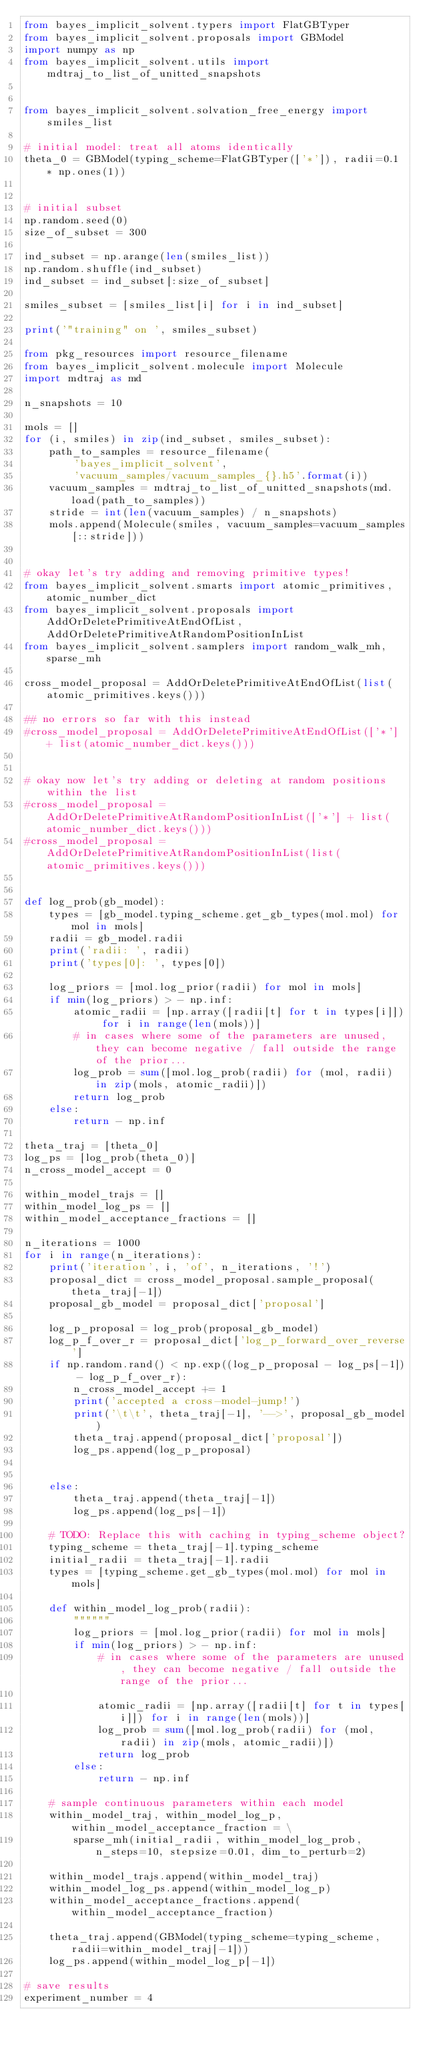Convert code to text. <code><loc_0><loc_0><loc_500><loc_500><_Python_>from bayes_implicit_solvent.typers import FlatGBTyper
from bayes_implicit_solvent.proposals import GBModel
import numpy as np
from bayes_implicit_solvent.utils import mdtraj_to_list_of_unitted_snapshots


from bayes_implicit_solvent.solvation_free_energy import smiles_list

# initial model: treat all atoms identically
theta_0 = GBModel(typing_scheme=FlatGBTyper(['*']), radii=0.1 * np.ones(1))


# initial subset
np.random.seed(0)
size_of_subset = 300

ind_subset = np.arange(len(smiles_list))
np.random.shuffle(ind_subset)
ind_subset = ind_subset[:size_of_subset]

smiles_subset = [smiles_list[i] for i in ind_subset]

print('"training" on ', smiles_subset)

from pkg_resources import resource_filename
from bayes_implicit_solvent.molecule import Molecule
import mdtraj as md

n_snapshots = 10

mols = []
for (i, smiles) in zip(ind_subset, smiles_subset):
    path_to_samples = resource_filename(
        'bayes_implicit_solvent',
        'vacuum_samples/vacuum_samples_{}.h5'.format(i))
    vacuum_samples = mdtraj_to_list_of_unitted_snapshots(md.load(path_to_samples))
    stride = int(len(vacuum_samples) / n_snapshots)
    mols.append(Molecule(smiles, vacuum_samples=vacuum_samples[::stride]))


# okay let's try adding and removing primitive types!
from bayes_implicit_solvent.smarts import atomic_primitives, atomic_number_dict
from bayes_implicit_solvent.proposals import AddOrDeletePrimitiveAtEndOfList, AddOrDeletePrimitiveAtRandomPositionInList
from bayes_implicit_solvent.samplers import random_walk_mh, sparse_mh

cross_model_proposal = AddOrDeletePrimitiveAtEndOfList(list(atomic_primitives.keys()))

## no errors so far with this instead
#cross_model_proposal = AddOrDeletePrimitiveAtEndOfList(['*'] + list(atomic_number_dict.keys()))


# okay now let's try adding or deleting at random positions within the list
#cross_model_proposal = AddOrDeletePrimitiveAtRandomPositionInList(['*'] + list(atomic_number_dict.keys()))
#cross_model_proposal = AddOrDeletePrimitiveAtRandomPositionInList(list(atomic_primitives.keys()))


def log_prob(gb_model):
    types = [gb_model.typing_scheme.get_gb_types(mol.mol) for mol in mols]
    radii = gb_model.radii
    print('radii: ', radii)
    print('types[0]: ', types[0])

    log_priors = [mol.log_prior(radii) for mol in mols]
    if min(log_priors) > - np.inf:
        atomic_radii = [np.array([radii[t] for t in types[i]]) for i in range(len(mols))]
        # in cases where some of the parameters are unused, they can become negative / fall outside the range of the prior...
        log_prob = sum([mol.log_prob(radii) for (mol, radii) in zip(mols, atomic_radii)])
        return log_prob
    else:
        return - np.inf

theta_traj = [theta_0]
log_ps = [log_prob(theta_0)]
n_cross_model_accept = 0

within_model_trajs = []
within_model_log_ps = []
within_model_acceptance_fractions = []

n_iterations = 1000
for i in range(n_iterations):
    print('iteration', i, 'of', n_iterations, '!')
    proposal_dict = cross_model_proposal.sample_proposal(theta_traj[-1])
    proposal_gb_model = proposal_dict['proposal']

    log_p_proposal = log_prob(proposal_gb_model)
    log_p_f_over_r = proposal_dict['log_p_forward_over_reverse']
    if np.random.rand() < np.exp((log_p_proposal - log_ps[-1]) - log_p_f_over_r):
        n_cross_model_accept += 1
        print('accepted a cross-model-jump!')
        print('\t\t', theta_traj[-1], '-->', proposal_gb_model)
        theta_traj.append(proposal_dict['proposal'])
        log_ps.append(log_p_proposal)


    else:
        theta_traj.append(theta_traj[-1])
        log_ps.append(log_ps[-1])

    # TODO: Replace this with caching in typing_scheme object?
    typing_scheme = theta_traj[-1].typing_scheme
    initial_radii = theta_traj[-1].radii
    types = [typing_scheme.get_gb_types(mol.mol) for mol in mols]

    def within_model_log_prob(radii):
        """"""
        log_priors = [mol.log_prior(radii) for mol in mols]
        if min(log_priors) > - np.inf:
            # in cases where some of the parameters are unused, they can become negative / fall outside the range of the prior...

            atomic_radii = [np.array([radii[t] for t in types[i]]) for i in range(len(mols))]
            log_prob = sum([mol.log_prob(radii) for (mol, radii) in zip(mols, atomic_radii)])
            return log_prob
        else:
            return - np.inf

    # sample continuous parameters within each model
    within_model_traj, within_model_log_p, within_model_acceptance_fraction = \
        sparse_mh(initial_radii, within_model_log_prob, n_steps=10, stepsize=0.01, dim_to_perturb=2)

    within_model_trajs.append(within_model_traj)
    within_model_log_ps.append(within_model_log_p)
    within_model_acceptance_fractions.append(within_model_acceptance_fraction)

    theta_traj.append(GBModel(typing_scheme=typing_scheme, radii=within_model_traj[-1]))
    log_ps.append(within_model_log_p[-1])

# save results
experiment_number = 4
</code> 